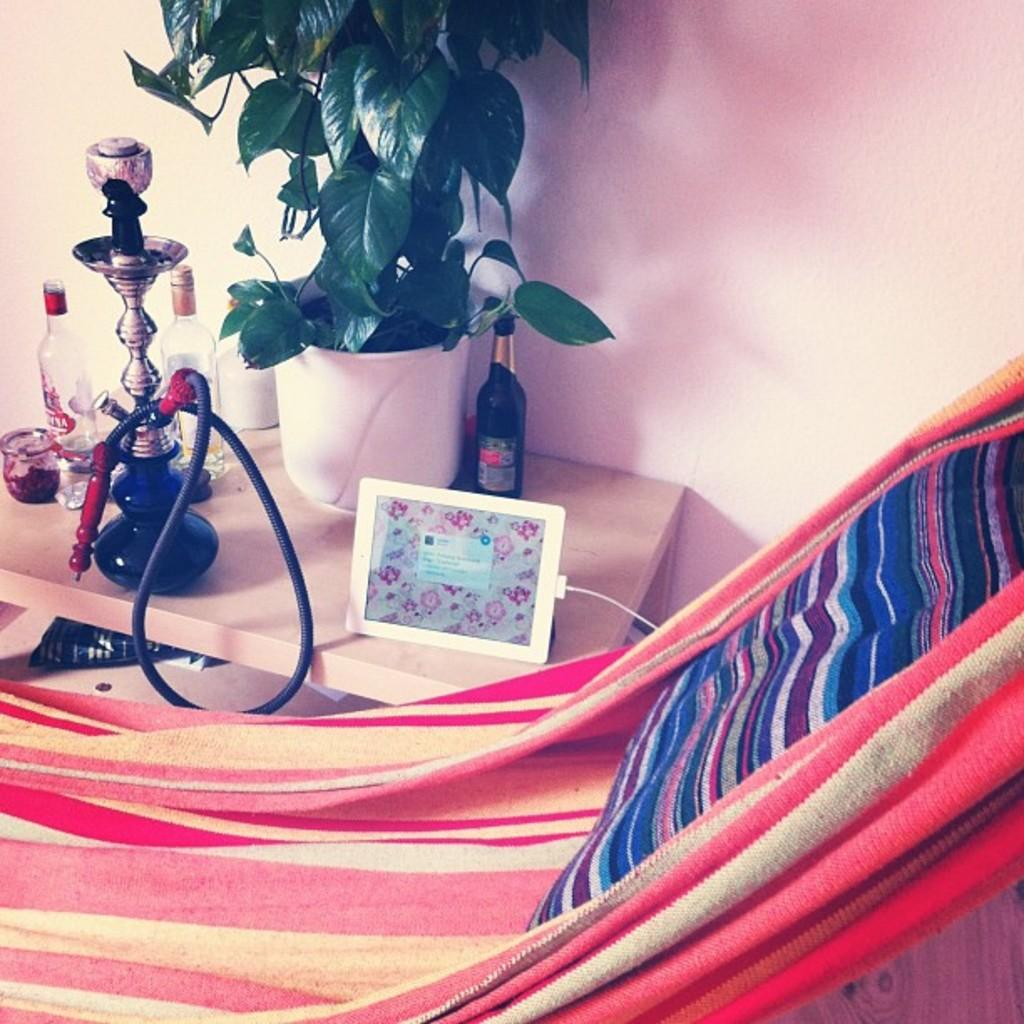What is the main piece of furniture in the image? There is a table in the image. What objects are placed on the table? A hukka pot, a vodka bottle, a plant, and an iPad are placed on the table. Is there any seating in the image? Yes, there is a chair in the image. What can be seen in the background of the image? There is a wall in the background of the image. What type of rake is used to maintain the plant in the image? There is no rake present in the image; only a plant is mentioned. What is the expansion plan for the table in the image? There is no information about expansion plans for the table in the image. 